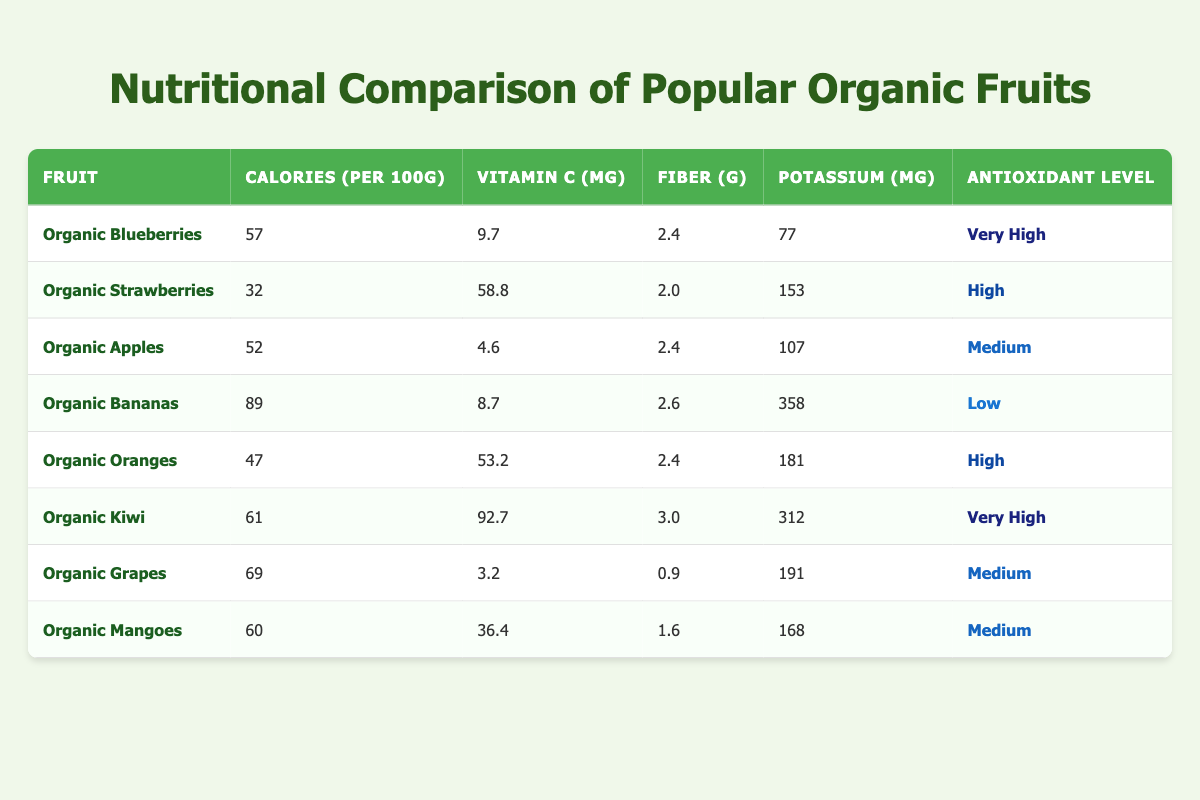What is the highest vitamin C content among the fruits listed? The table indicates that the fruit with the highest vitamin C content is Organic Kiwi with 92.7 mg per 100g.
Answer: Organic Kiwi Which fruit has the lowest calorie count per 100g? According to the table, the fruit with the lowest calorie count is Organic Strawberries with 32 calories per 100g.
Answer: Organic Strawberries Is it true that Organic Bananas have a higher potassium content than Organic Oranges? By examining the potassium levels, Organic Bananas have 358 mg, while Organic Oranges have 181 mg, so it is true that Organic Bananas have a higher potassium content.
Answer: Yes What is the average fiber content of the fruits listed? To find the average fiber content, we add the fiber values: 2.4 + 2.0 + 2.4 + 2.6 + 2.4 + 3.0 + 0.9 + 1.6 = 17.3. There are 8 fruits, so the average is 17.3 / 8 = 2.16 grams.
Answer: 2.16 grams Which fruits are classified as very high in antioxidants? The table shows that Organic Blueberries and Organic Kiwi are classified as very high in antioxidants.
Answer: Organic Blueberries, Organic Kiwi What is the difference in calories between Organic Mangoes and Organic Apples? Organic Mangoes have 60 calories, while Organic Apples have 52 calories. The difference is 60 - 52 = 8 calories.
Answer: 8 calories Do Organic Grapes have a higher antioxidant level than Organic Bananas? According to the table, Organic Grapes are classified as medium in antioxidants, while Organic Bananas are classified as low, so Organic Grapes have a higher antioxidant level.
Answer: Yes What is the potassium content of Organic Strawberries? The potassium content for Organic Strawberries listed in the table is 153 mg.
Answer: 153 mg 